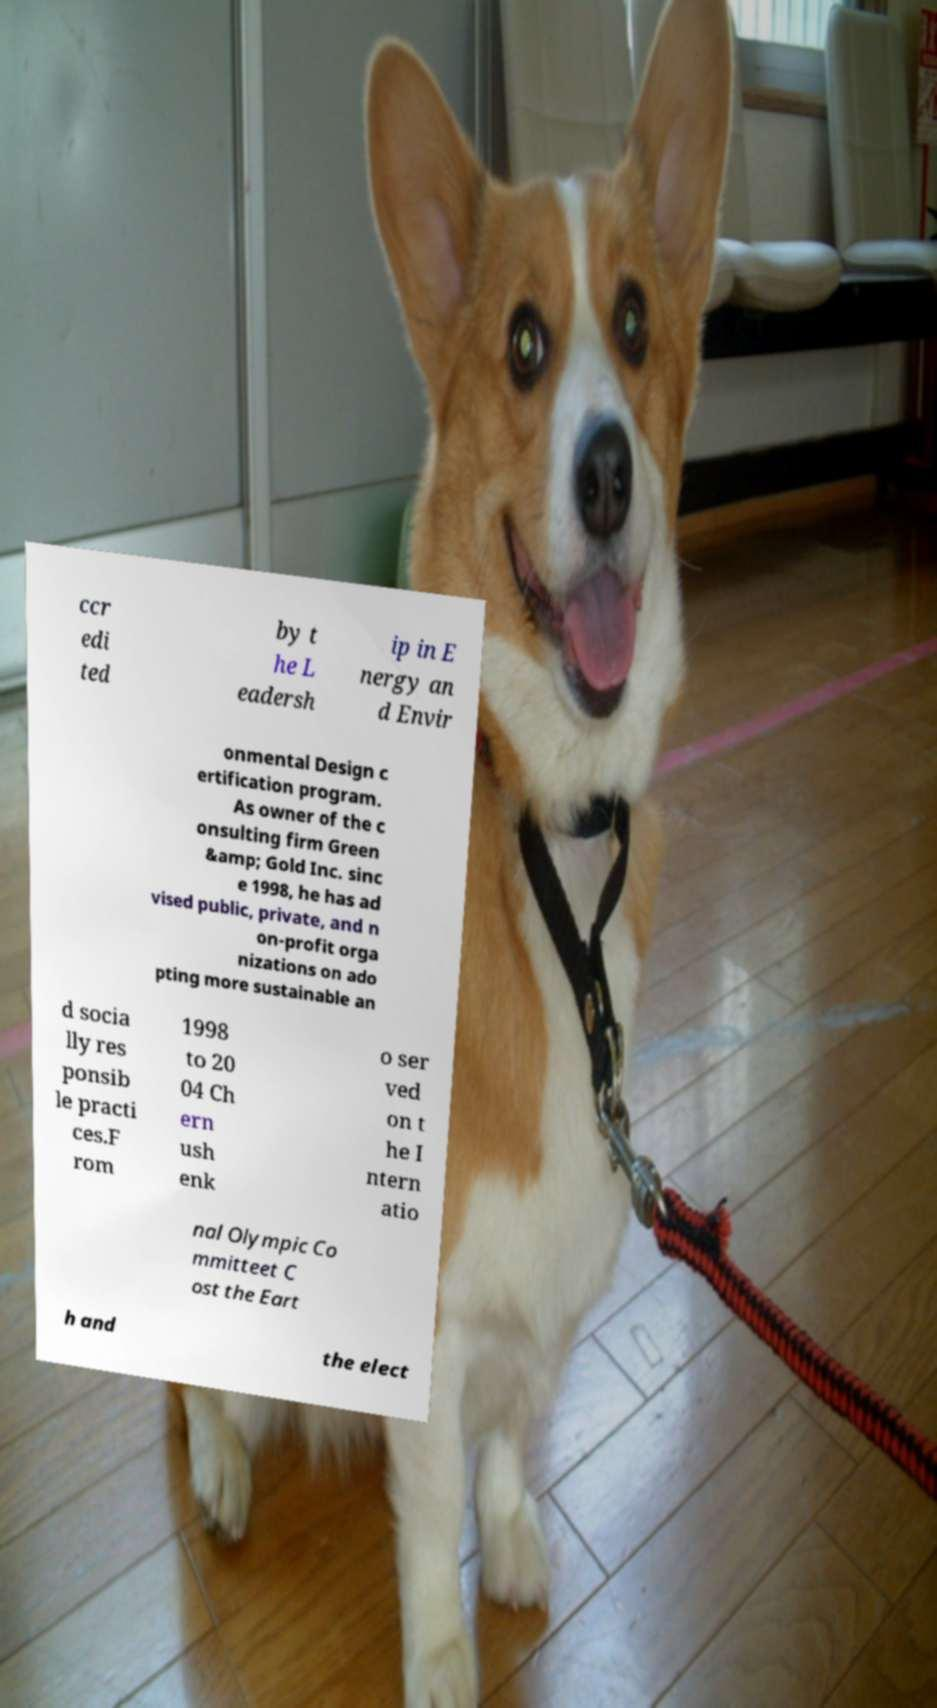Could you assist in decoding the text presented in this image and type it out clearly? ccr edi ted by t he L eadersh ip in E nergy an d Envir onmental Design c ertification program. As owner of the c onsulting firm Green &amp; Gold Inc. sinc e 1998, he has ad vised public, private, and n on-profit orga nizations on ado pting more sustainable an d socia lly res ponsib le practi ces.F rom 1998 to 20 04 Ch ern ush enk o ser ved on t he I ntern atio nal Olympic Co mmitteet C ost the Eart h and the elect 